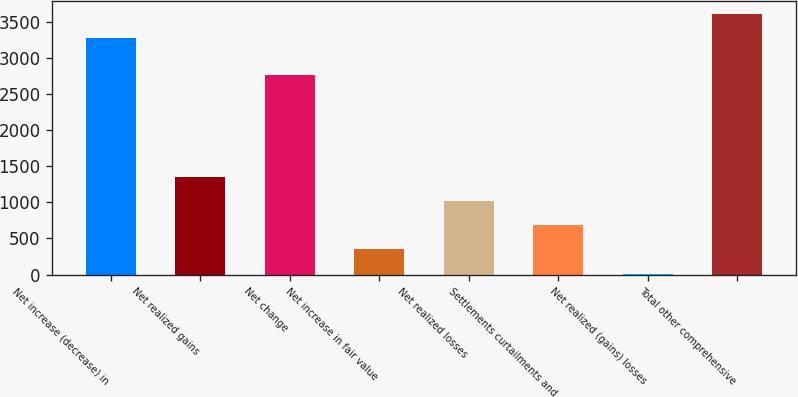Convert chart. <chart><loc_0><loc_0><loc_500><loc_500><bar_chart><fcel>Net increase (decrease) in<fcel>Net realized gains<fcel>Net change<fcel>Net increase in fair value<fcel>Net realized losses<fcel>Settlements curtailments and<fcel>Net realized (gains) losses<fcel>Total other comprehensive<nl><fcel>3268<fcel>1355.6<fcel>2760<fcel>347.9<fcel>1019.7<fcel>683.8<fcel>12<fcel>3603.9<nl></chart> 